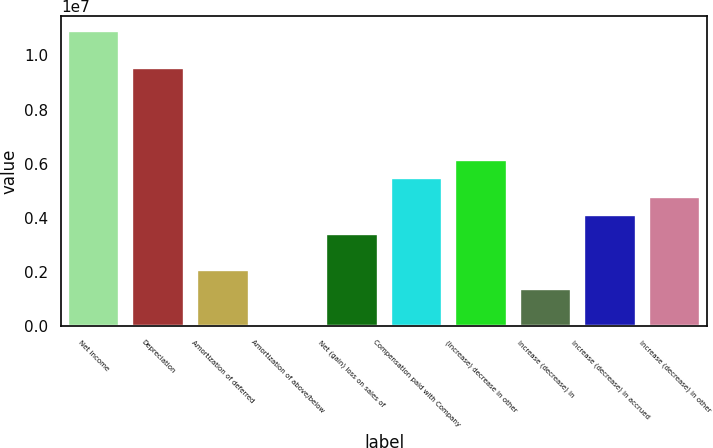Convert chart to OTSL. <chart><loc_0><loc_0><loc_500><loc_500><bar_chart><fcel>Net income<fcel>Depreciation<fcel>Amortization of deferred<fcel>Amortization of above/below<fcel>Net (gain) loss on sales of<fcel>Compensation paid with Company<fcel>(Increase) decrease in other<fcel>Increase (decrease) in<fcel>Increase (decrease) in accrued<fcel>Increase (decrease) in other<nl><fcel>1.09174e+07<fcel>9.55315e+06<fcel>2.0498e+06<fcel>3426<fcel>3.41404e+06<fcel>5.46041e+06<fcel>6.14254e+06<fcel>1.36767e+06<fcel>4.09617e+06<fcel>4.77829e+06<nl></chart> 